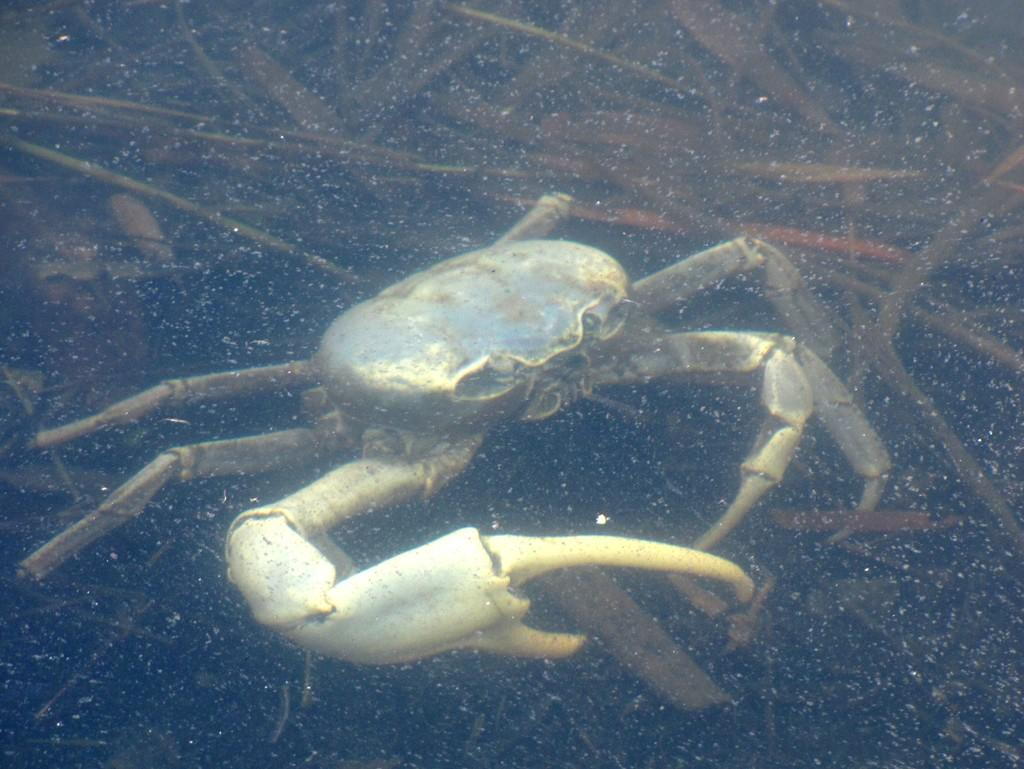What type of animal can be seen in the water in the image? There is a crab in the water in the image. What type of vegetation is visible at the top of the image? Grass is visible at the top of the image. What type of produce can be seen growing in the image? There is no produce visible in the image; it features a crab in the water and grass at the top. What sense is the crab using to navigate the water in the image? The image does not provide information about the crab's senses or how it is navigating the water. 